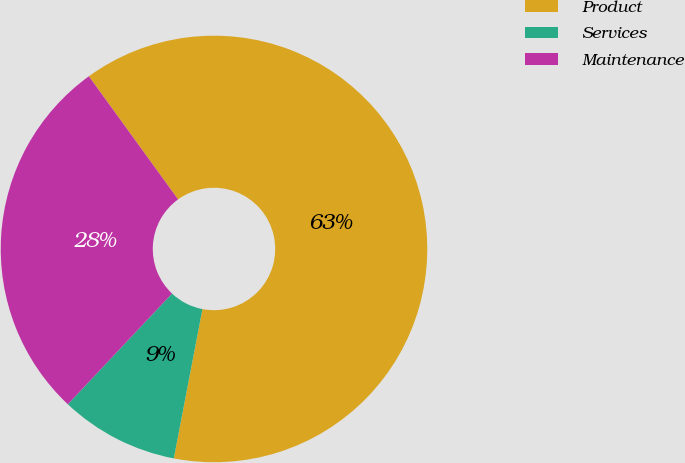<chart> <loc_0><loc_0><loc_500><loc_500><pie_chart><fcel>Product<fcel>Services<fcel>Maintenance<nl><fcel>63.0%<fcel>9.0%<fcel>28.0%<nl></chart> 